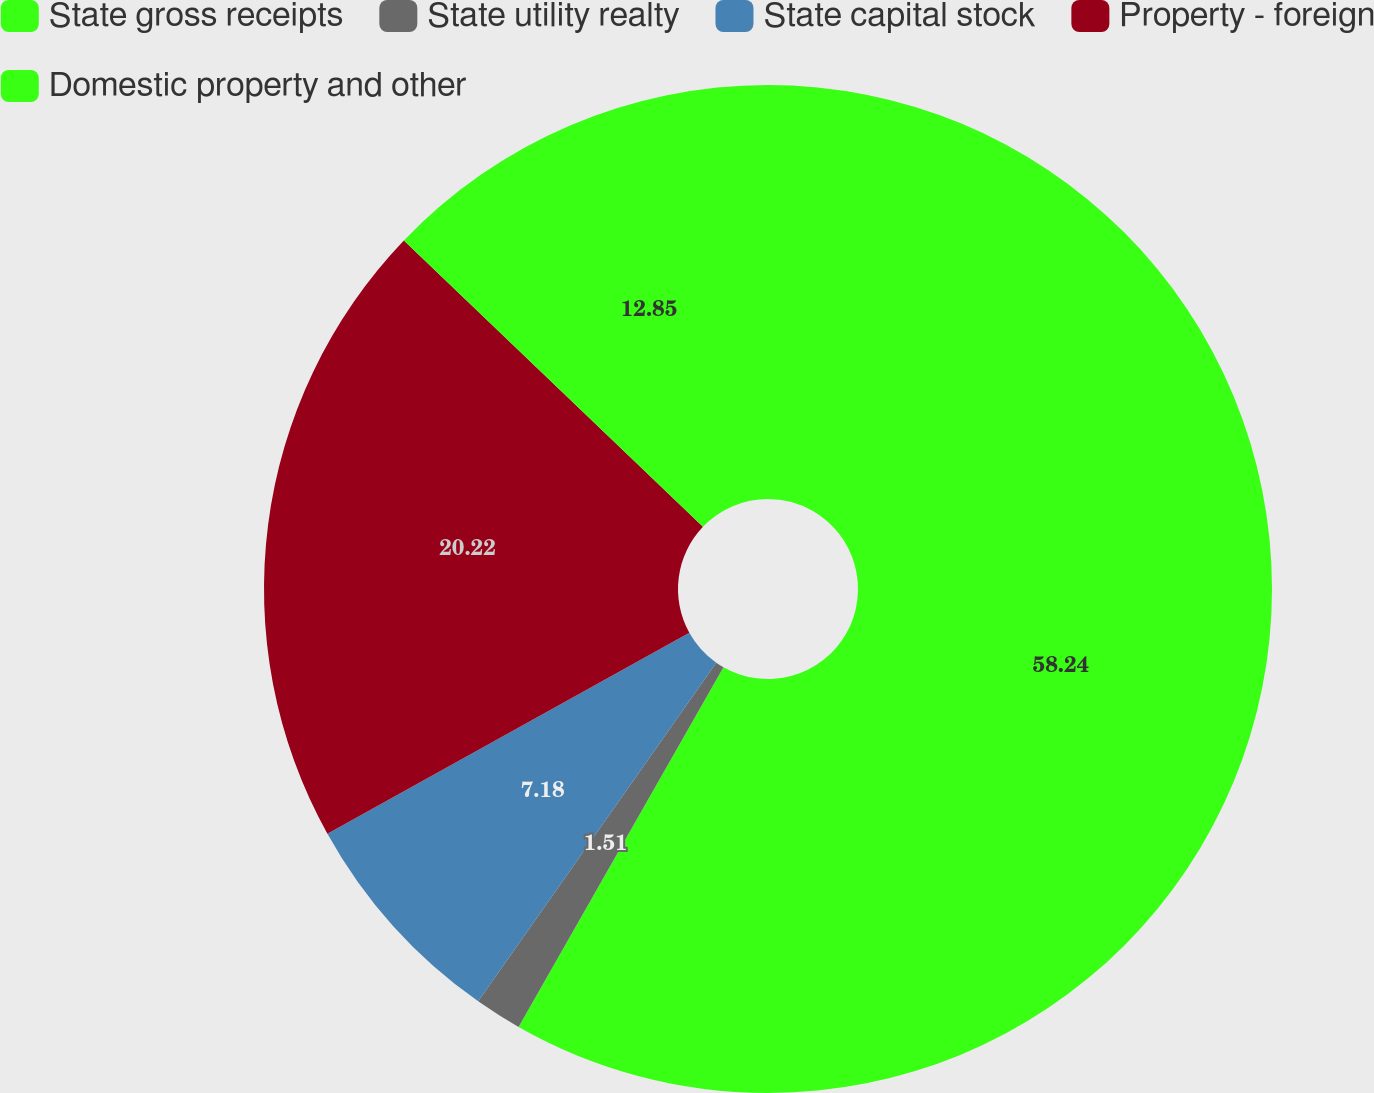<chart> <loc_0><loc_0><loc_500><loc_500><pie_chart><fcel>State gross receipts<fcel>State utility realty<fcel>State capital stock<fcel>Property - foreign<fcel>Domestic property and other<nl><fcel>58.24%<fcel>1.51%<fcel>7.18%<fcel>20.22%<fcel>12.85%<nl></chart> 